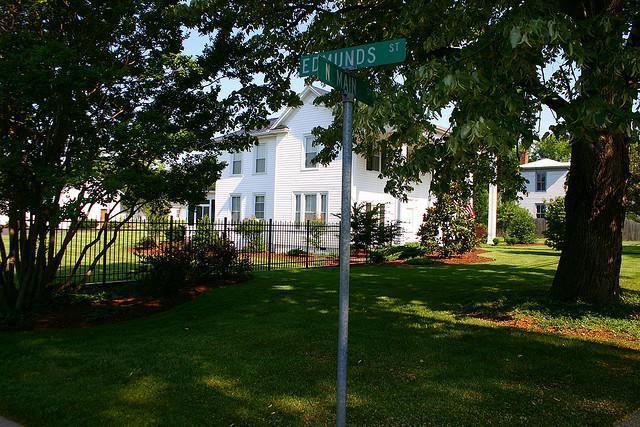How many vases are in the photo?
Give a very brief answer. 0. 